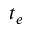<formula> <loc_0><loc_0><loc_500><loc_500>t _ { e }</formula> 